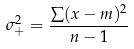Convert formula to latex. <formula><loc_0><loc_0><loc_500><loc_500>\sigma _ { + } ^ { 2 } = \frac { \sum ( x - m ) ^ { 2 } } { n - 1 }</formula> 